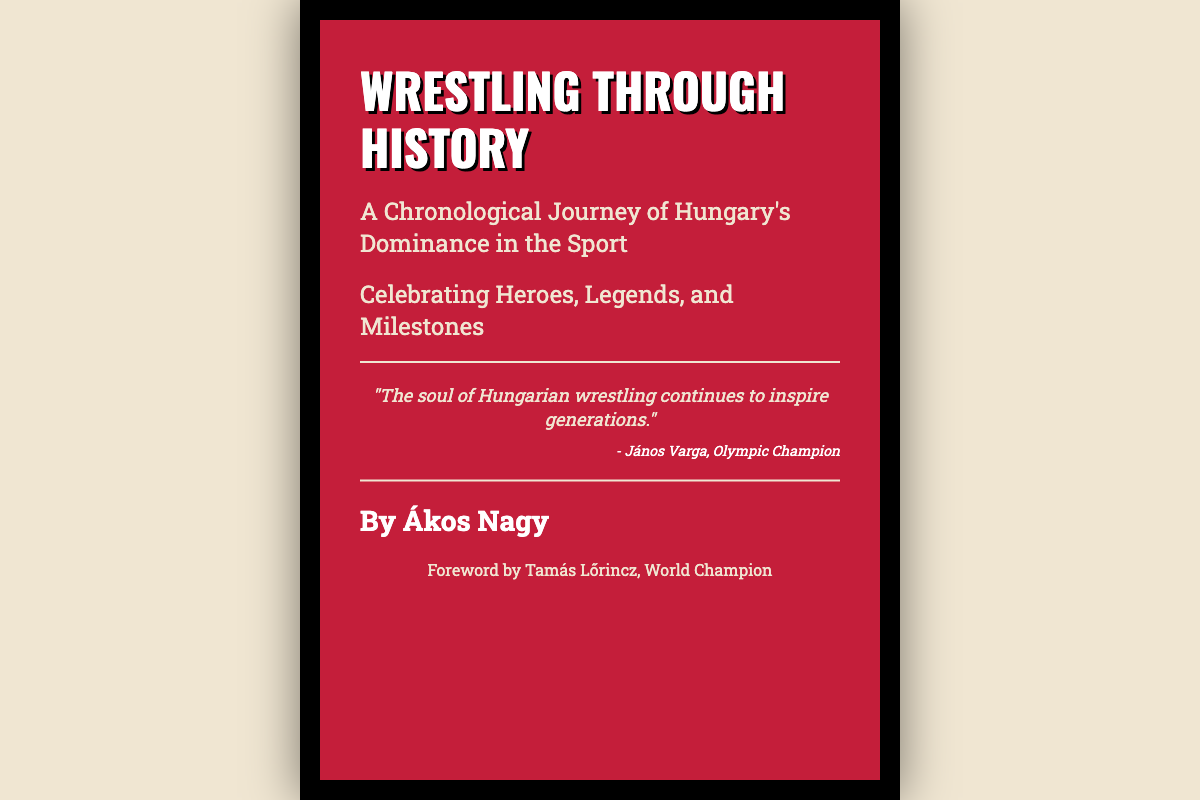What is the title of the book? The title is clearly stated at the top of the document.
Answer: Wrestling Through History Who is the author of the book? The author's name is mentioned at the bottom of the cover.
Answer: Ákos Nagy What is the subtitle of the book? The subtitle follows the main title and provides additional context.
Answer: A Chronological Journey of Hungary's Dominance in the Sport Who wrote the foreword for the book? The foreword is credited to a prominent individual in the wrestling community.
Answer: Tamás Lőrincz What quote is featured on the cover? A notable quote is displayed in the center of the document, giving insight into the spirit of the content.
Answer: "The soul of Hungarian wrestling continues to inspire generations." Who is the quoted author of the quote? The individual associated with the quote is noted directly beneath it.
Answer: János Varga What color is the book cover? The prominent color of the cover is an important visual aspect.
Answer: Red 